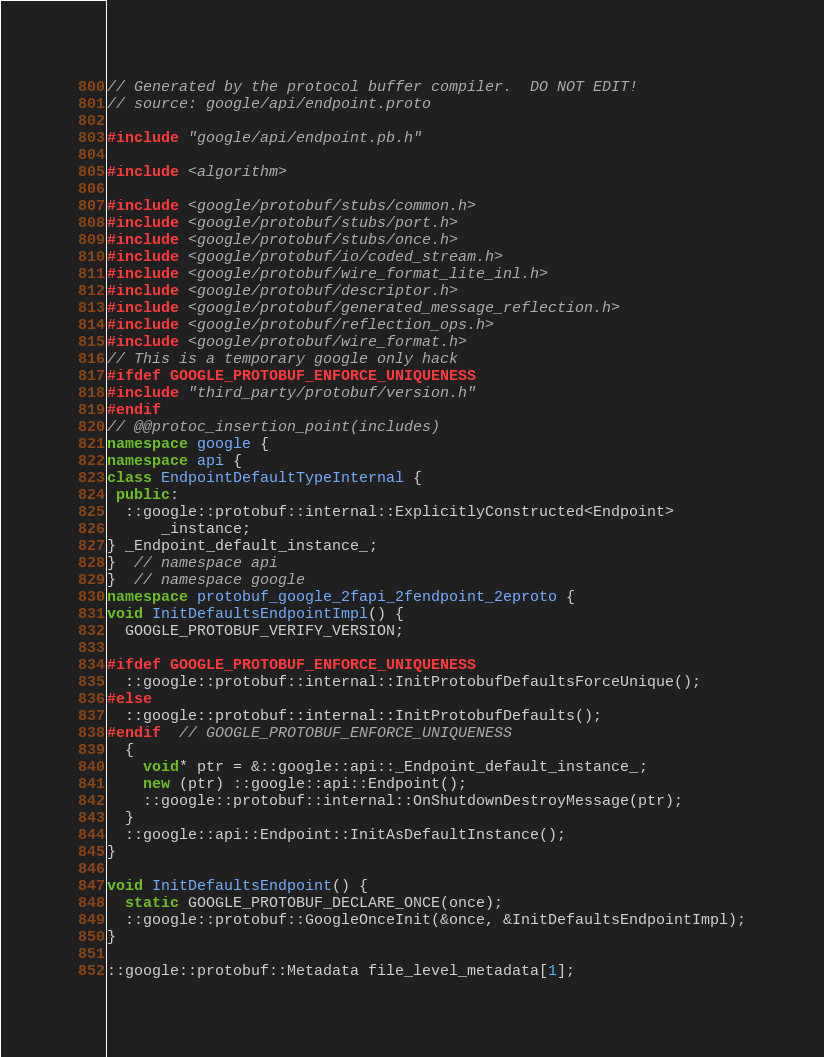Convert code to text. <code><loc_0><loc_0><loc_500><loc_500><_C++_>// Generated by the protocol buffer compiler.  DO NOT EDIT!
// source: google/api/endpoint.proto

#include "google/api/endpoint.pb.h"

#include <algorithm>

#include <google/protobuf/stubs/common.h>
#include <google/protobuf/stubs/port.h>
#include <google/protobuf/stubs/once.h>
#include <google/protobuf/io/coded_stream.h>
#include <google/protobuf/wire_format_lite_inl.h>
#include <google/protobuf/descriptor.h>
#include <google/protobuf/generated_message_reflection.h>
#include <google/protobuf/reflection_ops.h>
#include <google/protobuf/wire_format.h>
// This is a temporary google only hack
#ifdef GOOGLE_PROTOBUF_ENFORCE_UNIQUENESS
#include "third_party/protobuf/version.h"
#endif
// @@protoc_insertion_point(includes)
namespace google {
namespace api {
class EndpointDefaultTypeInternal {
 public:
  ::google::protobuf::internal::ExplicitlyConstructed<Endpoint>
      _instance;
} _Endpoint_default_instance_;
}  // namespace api
}  // namespace google
namespace protobuf_google_2fapi_2fendpoint_2eproto {
void InitDefaultsEndpointImpl() {
  GOOGLE_PROTOBUF_VERIFY_VERSION;

#ifdef GOOGLE_PROTOBUF_ENFORCE_UNIQUENESS
  ::google::protobuf::internal::InitProtobufDefaultsForceUnique();
#else
  ::google::protobuf::internal::InitProtobufDefaults();
#endif  // GOOGLE_PROTOBUF_ENFORCE_UNIQUENESS
  {
    void* ptr = &::google::api::_Endpoint_default_instance_;
    new (ptr) ::google::api::Endpoint();
    ::google::protobuf::internal::OnShutdownDestroyMessage(ptr);
  }
  ::google::api::Endpoint::InitAsDefaultInstance();
}

void InitDefaultsEndpoint() {
  static GOOGLE_PROTOBUF_DECLARE_ONCE(once);
  ::google::protobuf::GoogleOnceInit(&once, &InitDefaultsEndpointImpl);
}

::google::protobuf::Metadata file_level_metadata[1];
</code> 